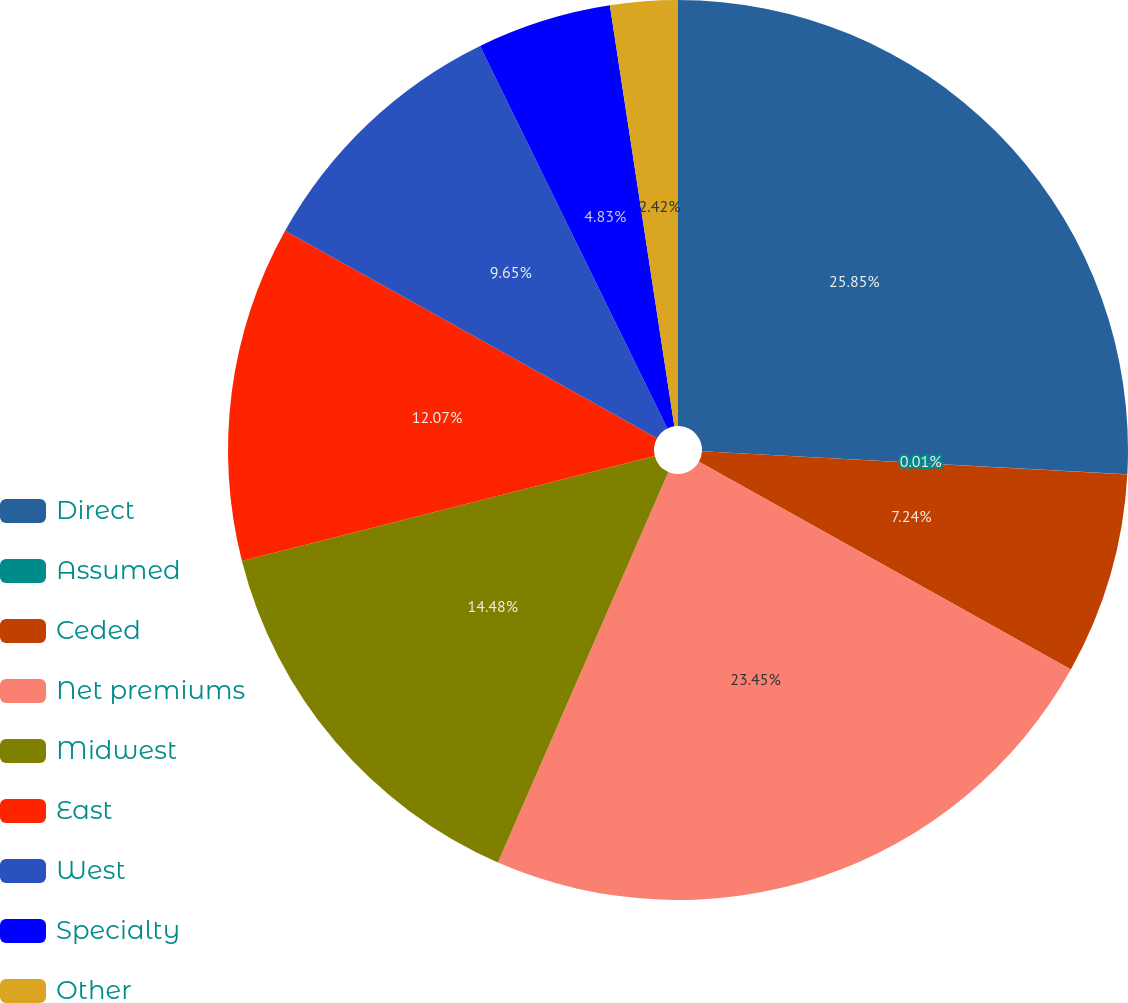Convert chart. <chart><loc_0><loc_0><loc_500><loc_500><pie_chart><fcel>Direct<fcel>Assumed<fcel>Ceded<fcel>Net premiums<fcel>Midwest<fcel>East<fcel>West<fcel>Specialty<fcel>Other<nl><fcel>25.86%<fcel>0.01%<fcel>7.24%<fcel>23.45%<fcel>14.48%<fcel>12.07%<fcel>9.65%<fcel>4.83%<fcel>2.42%<nl></chart> 